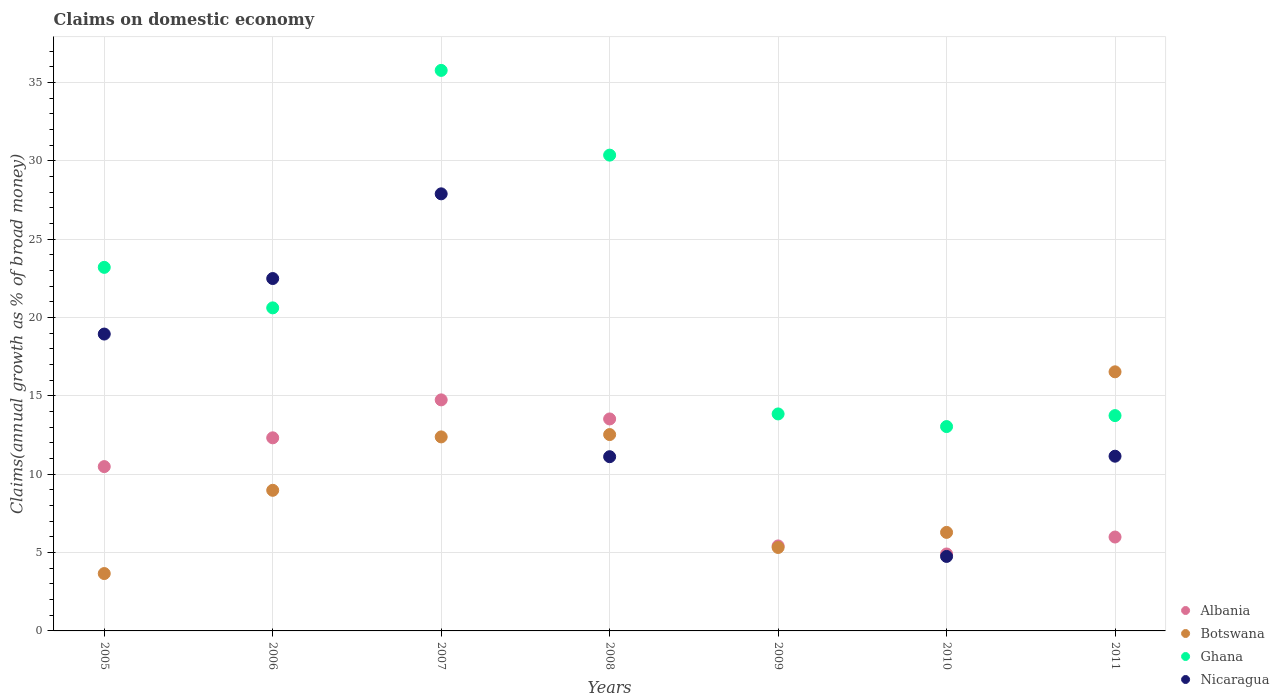What is the percentage of broad money claimed on domestic economy in Nicaragua in 2007?
Provide a succinct answer. 27.9. Across all years, what is the maximum percentage of broad money claimed on domestic economy in Albania?
Your answer should be very brief. 14.75. Across all years, what is the minimum percentage of broad money claimed on domestic economy in Ghana?
Your answer should be very brief. 13.04. In which year was the percentage of broad money claimed on domestic economy in Botswana maximum?
Offer a terse response. 2011. What is the total percentage of broad money claimed on domestic economy in Ghana in the graph?
Make the answer very short. 150.59. What is the difference between the percentage of broad money claimed on domestic economy in Albania in 2008 and that in 2010?
Offer a terse response. 8.62. What is the difference between the percentage of broad money claimed on domestic economy in Ghana in 2011 and the percentage of broad money claimed on domestic economy in Albania in 2007?
Your answer should be compact. -1. What is the average percentage of broad money claimed on domestic economy in Albania per year?
Your answer should be compact. 9.63. In the year 2008, what is the difference between the percentage of broad money claimed on domestic economy in Ghana and percentage of broad money claimed on domestic economy in Botswana?
Keep it short and to the point. 17.83. What is the ratio of the percentage of broad money claimed on domestic economy in Albania in 2008 to that in 2009?
Keep it short and to the point. 2.49. Is the percentage of broad money claimed on domestic economy in Albania in 2006 less than that in 2008?
Your answer should be very brief. Yes. What is the difference between the highest and the second highest percentage of broad money claimed on domestic economy in Botswana?
Your answer should be compact. 4. What is the difference between the highest and the lowest percentage of broad money claimed on domestic economy in Botswana?
Your answer should be very brief. 12.87. Is it the case that in every year, the sum of the percentage of broad money claimed on domestic economy in Botswana and percentage of broad money claimed on domestic economy in Nicaragua  is greater than the percentage of broad money claimed on domestic economy in Ghana?
Offer a terse response. No. Does the percentage of broad money claimed on domestic economy in Nicaragua monotonically increase over the years?
Your answer should be compact. No. Is the percentage of broad money claimed on domestic economy in Botswana strictly greater than the percentage of broad money claimed on domestic economy in Albania over the years?
Offer a very short reply. No. Is the percentage of broad money claimed on domestic economy in Albania strictly less than the percentage of broad money claimed on domestic economy in Nicaragua over the years?
Offer a terse response. No. Are the values on the major ticks of Y-axis written in scientific E-notation?
Your answer should be compact. No. Does the graph contain any zero values?
Offer a terse response. Yes. Where does the legend appear in the graph?
Offer a terse response. Bottom right. What is the title of the graph?
Offer a very short reply. Claims on domestic economy. What is the label or title of the Y-axis?
Offer a terse response. Claims(annual growth as % of broad money). What is the Claims(annual growth as % of broad money) in Albania in 2005?
Offer a terse response. 10.49. What is the Claims(annual growth as % of broad money) in Botswana in 2005?
Provide a short and direct response. 3.66. What is the Claims(annual growth as % of broad money) of Ghana in 2005?
Provide a short and direct response. 23.2. What is the Claims(annual growth as % of broad money) in Nicaragua in 2005?
Provide a short and direct response. 18.95. What is the Claims(annual growth as % of broad money) of Albania in 2006?
Offer a very short reply. 12.32. What is the Claims(annual growth as % of broad money) of Botswana in 2006?
Provide a short and direct response. 8.97. What is the Claims(annual growth as % of broad money) in Ghana in 2006?
Keep it short and to the point. 20.62. What is the Claims(annual growth as % of broad money) of Nicaragua in 2006?
Give a very brief answer. 22.49. What is the Claims(annual growth as % of broad money) in Albania in 2007?
Your response must be concise. 14.75. What is the Claims(annual growth as % of broad money) in Botswana in 2007?
Offer a very short reply. 12.38. What is the Claims(annual growth as % of broad money) of Ghana in 2007?
Your response must be concise. 35.77. What is the Claims(annual growth as % of broad money) of Nicaragua in 2007?
Your response must be concise. 27.9. What is the Claims(annual growth as % of broad money) of Albania in 2008?
Provide a succinct answer. 13.53. What is the Claims(annual growth as % of broad money) in Botswana in 2008?
Make the answer very short. 12.53. What is the Claims(annual growth as % of broad money) in Ghana in 2008?
Make the answer very short. 30.37. What is the Claims(annual growth as % of broad money) in Nicaragua in 2008?
Provide a short and direct response. 11.12. What is the Claims(annual growth as % of broad money) of Albania in 2009?
Offer a very short reply. 5.42. What is the Claims(annual growth as % of broad money) in Botswana in 2009?
Provide a succinct answer. 5.33. What is the Claims(annual growth as % of broad money) in Ghana in 2009?
Make the answer very short. 13.85. What is the Claims(annual growth as % of broad money) in Nicaragua in 2009?
Your response must be concise. 0. What is the Claims(annual growth as % of broad money) in Albania in 2010?
Ensure brevity in your answer.  4.91. What is the Claims(annual growth as % of broad money) in Botswana in 2010?
Your response must be concise. 6.29. What is the Claims(annual growth as % of broad money) in Ghana in 2010?
Provide a short and direct response. 13.04. What is the Claims(annual growth as % of broad money) of Nicaragua in 2010?
Offer a very short reply. 4.75. What is the Claims(annual growth as % of broad money) in Albania in 2011?
Offer a very short reply. 5.99. What is the Claims(annual growth as % of broad money) in Botswana in 2011?
Give a very brief answer. 16.54. What is the Claims(annual growth as % of broad money) in Ghana in 2011?
Provide a succinct answer. 13.74. What is the Claims(annual growth as % of broad money) in Nicaragua in 2011?
Offer a terse response. 11.15. Across all years, what is the maximum Claims(annual growth as % of broad money) in Albania?
Ensure brevity in your answer.  14.75. Across all years, what is the maximum Claims(annual growth as % of broad money) in Botswana?
Ensure brevity in your answer.  16.54. Across all years, what is the maximum Claims(annual growth as % of broad money) in Ghana?
Keep it short and to the point. 35.77. Across all years, what is the maximum Claims(annual growth as % of broad money) of Nicaragua?
Keep it short and to the point. 27.9. Across all years, what is the minimum Claims(annual growth as % of broad money) in Albania?
Your response must be concise. 4.91. Across all years, what is the minimum Claims(annual growth as % of broad money) in Botswana?
Keep it short and to the point. 3.66. Across all years, what is the minimum Claims(annual growth as % of broad money) of Ghana?
Make the answer very short. 13.04. What is the total Claims(annual growth as % of broad money) in Albania in the graph?
Offer a terse response. 67.41. What is the total Claims(annual growth as % of broad money) in Botswana in the graph?
Provide a short and direct response. 65.7. What is the total Claims(annual growth as % of broad money) of Ghana in the graph?
Your answer should be compact. 150.59. What is the total Claims(annual growth as % of broad money) in Nicaragua in the graph?
Keep it short and to the point. 96.36. What is the difference between the Claims(annual growth as % of broad money) in Albania in 2005 and that in 2006?
Your response must be concise. -1.84. What is the difference between the Claims(annual growth as % of broad money) in Botswana in 2005 and that in 2006?
Keep it short and to the point. -5.31. What is the difference between the Claims(annual growth as % of broad money) of Ghana in 2005 and that in 2006?
Offer a terse response. 2.59. What is the difference between the Claims(annual growth as % of broad money) of Nicaragua in 2005 and that in 2006?
Provide a short and direct response. -3.54. What is the difference between the Claims(annual growth as % of broad money) of Albania in 2005 and that in 2007?
Ensure brevity in your answer.  -4.26. What is the difference between the Claims(annual growth as % of broad money) of Botswana in 2005 and that in 2007?
Make the answer very short. -8.72. What is the difference between the Claims(annual growth as % of broad money) in Ghana in 2005 and that in 2007?
Give a very brief answer. -12.57. What is the difference between the Claims(annual growth as % of broad money) of Nicaragua in 2005 and that in 2007?
Offer a terse response. -8.95. What is the difference between the Claims(annual growth as % of broad money) of Albania in 2005 and that in 2008?
Make the answer very short. -3.04. What is the difference between the Claims(annual growth as % of broad money) in Botswana in 2005 and that in 2008?
Ensure brevity in your answer.  -8.87. What is the difference between the Claims(annual growth as % of broad money) of Ghana in 2005 and that in 2008?
Ensure brevity in your answer.  -7.16. What is the difference between the Claims(annual growth as % of broad money) in Nicaragua in 2005 and that in 2008?
Give a very brief answer. 7.83. What is the difference between the Claims(annual growth as % of broad money) in Albania in 2005 and that in 2009?
Give a very brief answer. 5.06. What is the difference between the Claims(annual growth as % of broad money) in Botswana in 2005 and that in 2009?
Offer a terse response. -1.66. What is the difference between the Claims(annual growth as % of broad money) in Ghana in 2005 and that in 2009?
Ensure brevity in your answer.  9.35. What is the difference between the Claims(annual growth as % of broad money) in Albania in 2005 and that in 2010?
Your answer should be very brief. 5.58. What is the difference between the Claims(annual growth as % of broad money) in Botswana in 2005 and that in 2010?
Offer a very short reply. -2.63. What is the difference between the Claims(annual growth as % of broad money) of Ghana in 2005 and that in 2010?
Make the answer very short. 10.16. What is the difference between the Claims(annual growth as % of broad money) of Nicaragua in 2005 and that in 2010?
Provide a short and direct response. 14.19. What is the difference between the Claims(annual growth as % of broad money) in Albania in 2005 and that in 2011?
Provide a short and direct response. 4.49. What is the difference between the Claims(annual growth as % of broad money) of Botswana in 2005 and that in 2011?
Your response must be concise. -12.87. What is the difference between the Claims(annual growth as % of broad money) of Ghana in 2005 and that in 2011?
Ensure brevity in your answer.  9.46. What is the difference between the Claims(annual growth as % of broad money) of Nicaragua in 2005 and that in 2011?
Keep it short and to the point. 7.8. What is the difference between the Claims(annual growth as % of broad money) of Albania in 2006 and that in 2007?
Ensure brevity in your answer.  -2.42. What is the difference between the Claims(annual growth as % of broad money) of Botswana in 2006 and that in 2007?
Offer a very short reply. -3.41. What is the difference between the Claims(annual growth as % of broad money) in Ghana in 2006 and that in 2007?
Keep it short and to the point. -15.16. What is the difference between the Claims(annual growth as % of broad money) of Nicaragua in 2006 and that in 2007?
Your answer should be compact. -5.41. What is the difference between the Claims(annual growth as % of broad money) of Albania in 2006 and that in 2008?
Keep it short and to the point. -1.2. What is the difference between the Claims(annual growth as % of broad money) in Botswana in 2006 and that in 2008?
Offer a very short reply. -3.56. What is the difference between the Claims(annual growth as % of broad money) of Ghana in 2006 and that in 2008?
Offer a terse response. -9.75. What is the difference between the Claims(annual growth as % of broad money) of Nicaragua in 2006 and that in 2008?
Your answer should be very brief. 11.37. What is the difference between the Claims(annual growth as % of broad money) of Albania in 2006 and that in 2009?
Offer a terse response. 6.9. What is the difference between the Claims(annual growth as % of broad money) in Botswana in 2006 and that in 2009?
Provide a succinct answer. 3.65. What is the difference between the Claims(annual growth as % of broad money) of Ghana in 2006 and that in 2009?
Make the answer very short. 6.77. What is the difference between the Claims(annual growth as % of broad money) of Albania in 2006 and that in 2010?
Keep it short and to the point. 7.41. What is the difference between the Claims(annual growth as % of broad money) in Botswana in 2006 and that in 2010?
Your response must be concise. 2.69. What is the difference between the Claims(annual growth as % of broad money) in Ghana in 2006 and that in 2010?
Offer a very short reply. 7.58. What is the difference between the Claims(annual growth as % of broad money) of Nicaragua in 2006 and that in 2010?
Make the answer very short. 17.74. What is the difference between the Claims(annual growth as % of broad money) of Albania in 2006 and that in 2011?
Provide a succinct answer. 6.33. What is the difference between the Claims(annual growth as % of broad money) of Botswana in 2006 and that in 2011?
Make the answer very short. -7.56. What is the difference between the Claims(annual growth as % of broad money) of Ghana in 2006 and that in 2011?
Offer a very short reply. 6.88. What is the difference between the Claims(annual growth as % of broad money) of Nicaragua in 2006 and that in 2011?
Keep it short and to the point. 11.34. What is the difference between the Claims(annual growth as % of broad money) of Albania in 2007 and that in 2008?
Provide a short and direct response. 1.22. What is the difference between the Claims(annual growth as % of broad money) of Botswana in 2007 and that in 2008?
Provide a short and direct response. -0.15. What is the difference between the Claims(annual growth as % of broad money) in Ghana in 2007 and that in 2008?
Your response must be concise. 5.41. What is the difference between the Claims(annual growth as % of broad money) of Nicaragua in 2007 and that in 2008?
Your answer should be compact. 16.78. What is the difference between the Claims(annual growth as % of broad money) in Albania in 2007 and that in 2009?
Ensure brevity in your answer.  9.32. What is the difference between the Claims(annual growth as % of broad money) of Botswana in 2007 and that in 2009?
Your answer should be very brief. 7.06. What is the difference between the Claims(annual growth as % of broad money) in Ghana in 2007 and that in 2009?
Provide a short and direct response. 21.92. What is the difference between the Claims(annual growth as % of broad money) of Albania in 2007 and that in 2010?
Offer a terse response. 9.84. What is the difference between the Claims(annual growth as % of broad money) of Botswana in 2007 and that in 2010?
Provide a short and direct response. 6.09. What is the difference between the Claims(annual growth as % of broad money) in Ghana in 2007 and that in 2010?
Give a very brief answer. 22.73. What is the difference between the Claims(annual growth as % of broad money) in Nicaragua in 2007 and that in 2010?
Make the answer very short. 23.14. What is the difference between the Claims(annual growth as % of broad money) of Albania in 2007 and that in 2011?
Make the answer very short. 8.75. What is the difference between the Claims(annual growth as % of broad money) of Botswana in 2007 and that in 2011?
Your answer should be compact. -4.15. What is the difference between the Claims(annual growth as % of broad money) of Ghana in 2007 and that in 2011?
Keep it short and to the point. 22.03. What is the difference between the Claims(annual growth as % of broad money) of Nicaragua in 2007 and that in 2011?
Give a very brief answer. 16.74. What is the difference between the Claims(annual growth as % of broad money) of Albania in 2008 and that in 2009?
Keep it short and to the point. 8.1. What is the difference between the Claims(annual growth as % of broad money) of Botswana in 2008 and that in 2009?
Your response must be concise. 7.21. What is the difference between the Claims(annual growth as % of broad money) of Ghana in 2008 and that in 2009?
Offer a terse response. 16.52. What is the difference between the Claims(annual growth as % of broad money) of Albania in 2008 and that in 2010?
Your answer should be compact. 8.62. What is the difference between the Claims(annual growth as % of broad money) in Botswana in 2008 and that in 2010?
Provide a short and direct response. 6.24. What is the difference between the Claims(annual growth as % of broad money) in Ghana in 2008 and that in 2010?
Make the answer very short. 17.32. What is the difference between the Claims(annual growth as % of broad money) in Nicaragua in 2008 and that in 2010?
Offer a very short reply. 6.37. What is the difference between the Claims(annual growth as % of broad money) of Albania in 2008 and that in 2011?
Provide a short and direct response. 7.54. What is the difference between the Claims(annual growth as % of broad money) in Botswana in 2008 and that in 2011?
Your answer should be very brief. -4. What is the difference between the Claims(annual growth as % of broad money) in Ghana in 2008 and that in 2011?
Ensure brevity in your answer.  16.62. What is the difference between the Claims(annual growth as % of broad money) in Nicaragua in 2008 and that in 2011?
Give a very brief answer. -0.03. What is the difference between the Claims(annual growth as % of broad money) in Albania in 2009 and that in 2010?
Make the answer very short. 0.51. What is the difference between the Claims(annual growth as % of broad money) in Botswana in 2009 and that in 2010?
Provide a short and direct response. -0.96. What is the difference between the Claims(annual growth as % of broad money) of Ghana in 2009 and that in 2010?
Provide a succinct answer. 0.81. What is the difference between the Claims(annual growth as % of broad money) of Albania in 2009 and that in 2011?
Give a very brief answer. -0.57. What is the difference between the Claims(annual growth as % of broad money) in Botswana in 2009 and that in 2011?
Your answer should be very brief. -11.21. What is the difference between the Claims(annual growth as % of broad money) of Ghana in 2009 and that in 2011?
Ensure brevity in your answer.  0.11. What is the difference between the Claims(annual growth as % of broad money) of Albania in 2010 and that in 2011?
Make the answer very short. -1.08. What is the difference between the Claims(annual growth as % of broad money) in Botswana in 2010 and that in 2011?
Ensure brevity in your answer.  -10.25. What is the difference between the Claims(annual growth as % of broad money) of Nicaragua in 2010 and that in 2011?
Your response must be concise. -6.4. What is the difference between the Claims(annual growth as % of broad money) of Albania in 2005 and the Claims(annual growth as % of broad money) of Botswana in 2006?
Your answer should be very brief. 1.51. What is the difference between the Claims(annual growth as % of broad money) of Albania in 2005 and the Claims(annual growth as % of broad money) of Ghana in 2006?
Your response must be concise. -10.13. What is the difference between the Claims(annual growth as % of broad money) in Albania in 2005 and the Claims(annual growth as % of broad money) in Nicaragua in 2006?
Ensure brevity in your answer.  -12. What is the difference between the Claims(annual growth as % of broad money) in Botswana in 2005 and the Claims(annual growth as % of broad money) in Ghana in 2006?
Give a very brief answer. -16.96. What is the difference between the Claims(annual growth as % of broad money) of Botswana in 2005 and the Claims(annual growth as % of broad money) of Nicaragua in 2006?
Your response must be concise. -18.83. What is the difference between the Claims(annual growth as % of broad money) of Ghana in 2005 and the Claims(annual growth as % of broad money) of Nicaragua in 2006?
Make the answer very short. 0.71. What is the difference between the Claims(annual growth as % of broad money) in Albania in 2005 and the Claims(annual growth as % of broad money) in Botswana in 2007?
Offer a terse response. -1.9. What is the difference between the Claims(annual growth as % of broad money) of Albania in 2005 and the Claims(annual growth as % of broad money) of Ghana in 2007?
Your answer should be very brief. -25.29. What is the difference between the Claims(annual growth as % of broad money) of Albania in 2005 and the Claims(annual growth as % of broad money) of Nicaragua in 2007?
Offer a terse response. -17.41. What is the difference between the Claims(annual growth as % of broad money) of Botswana in 2005 and the Claims(annual growth as % of broad money) of Ghana in 2007?
Make the answer very short. -32.11. What is the difference between the Claims(annual growth as % of broad money) of Botswana in 2005 and the Claims(annual growth as % of broad money) of Nicaragua in 2007?
Your answer should be compact. -24.23. What is the difference between the Claims(annual growth as % of broad money) of Ghana in 2005 and the Claims(annual growth as % of broad money) of Nicaragua in 2007?
Your answer should be compact. -4.69. What is the difference between the Claims(annual growth as % of broad money) in Albania in 2005 and the Claims(annual growth as % of broad money) in Botswana in 2008?
Offer a very short reply. -2.04. What is the difference between the Claims(annual growth as % of broad money) in Albania in 2005 and the Claims(annual growth as % of broad money) in Ghana in 2008?
Provide a succinct answer. -19.88. What is the difference between the Claims(annual growth as % of broad money) in Albania in 2005 and the Claims(annual growth as % of broad money) in Nicaragua in 2008?
Give a very brief answer. -0.63. What is the difference between the Claims(annual growth as % of broad money) in Botswana in 2005 and the Claims(annual growth as % of broad money) in Ghana in 2008?
Offer a terse response. -26.7. What is the difference between the Claims(annual growth as % of broad money) in Botswana in 2005 and the Claims(annual growth as % of broad money) in Nicaragua in 2008?
Your answer should be very brief. -7.46. What is the difference between the Claims(annual growth as % of broad money) of Ghana in 2005 and the Claims(annual growth as % of broad money) of Nicaragua in 2008?
Give a very brief answer. 12.08. What is the difference between the Claims(annual growth as % of broad money) of Albania in 2005 and the Claims(annual growth as % of broad money) of Botswana in 2009?
Your answer should be compact. 5.16. What is the difference between the Claims(annual growth as % of broad money) of Albania in 2005 and the Claims(annual growth as % of broad money) of Ghana in 2009?
Offer a very short reply. -3.36. What is the difference between the Claims(annual growth as % of broad money) of Botswana in 2005 and the Claims(annual growth as % of broad money) of Ghana in 2009?
Keep it short and to the point. -10.19. What is the difference between the Claims(annual growth as % of broad money) in Albania in 2005 and the Claims(annual growth as % of broad money) in Botswana in 2010?
Make the answer very short. 4.2. What is the difference between the Claims(annual growth as % of broad money) in Albania in 2005 and the Claims(annual growth as % of broad money) in Ghana in 2010?
Your response must be concise. -2.55. What is the difference between the Claims(annual growth as % of broad money) of Albania in 2005 and the Claims(annual growth as % of broad money) of Nicaragua in 2010?
Give a very brief answer. 5.73. What is the difference between the Claims(annual growth as % of broad money) of Botswana in 2005 and the Claims(annual growth as % of broad money) of Ghana in 2010?
Your answer should be very brief. -9.38. What is the difference between the Claims(annual growth as % of broad money) in Botswana in 2005 and the Claims(annual growth as % of broad money) in Nicaragua in 2010?
Offer a very short reply. -1.09. What is the difference between the Claims(annual growth as % of broad money) of Ghana in 2005 and the Claims(annual growth as % of broad money) of Nicaragua in 2010?
Make the answer very short. 18.45. What is the difference between the Claims(annual growth as % of broad money) of Albania in 2005 and the Claims(annual growth as % of broad money) of Botswana in 2011?
Provide a succinct answer. -6.05. What is the difference between the Claims(annual growth as % of broad money) in Albania in 2005 and the Claims(annual growth as % of broad money) in Ghana in 2011?
Your response must be concise. -3.25. What is the difference between the Claims(annual growth as % of broad money) in Albania in 2005 and the Claims(annual growth as % of broad money) in Nicaragua in 2011?
Offer a terse response. -0.66. What is the difference between the Claims(annual growth as % of broad money) in Botswana in 2005 and the Claims(annual growth as % of broad money) in Ghana in 2011?
Your response must be concise. -10.08. What is the difference between the Claims(annual growth as % of broad money) of Botswana in 2005 and the Claims(annual growth as % of broad money) of Nicaragua in 2011?
Keep it short and to the point. -7.49. What is the difference between the Claims(annual growth as % of broad money) in Ghana in 2005 and the Claims(annual growth as % of broad money) in Nicaragua in 2011?
Provide a short and direct response. 12.05. What is the difference between the Claims(annual growth as % of broad money) in Albania in 2006 and the Claims(annual growth as % of broad money) in Botswana in 2007?
Ensure brevity in your answer.  -0.06. What is the difference between the Claims(annual growth as % of broad money) in Albania in 2006 and the Claims(annual growth as % of broad money) in Ghana in 2007?
Provide a succinct answer. -23.45. What is the difference between the Claims(annual growth as % of broad money) of Albania in 2006 and the Claims(annual growth as % of broad money) of Nicaragua in 2007?
Keep it short and to the point. -15.57. What is the difference between the Claims(annual growth as % of broad money) in Botswana in 2006 and the Claims(annual growth as % of broad money) in Ghana in 2007?
Give a very brief answer. -26.8. What is the difference between the Claims(annual growth as % of broad money) in Botswana in 2006 and the Claims(annual growth as % of broad money) in Nicaragua in 2007?
Keep it short and to the point. -18.92. What is the difference between the Claims(annual growth as % of broad money) in Ghana in 2006 and the Claims(annual growth as % of broad money) in Nicaragua in 2007?
Provide a succinct answer. -7.28. What is the difference between the Claims(annual growth as % of broad money) of Albania in 2006 and the Claims(annual growth as % of broad money) of Botswana in 2008?
Make the answer very short. -0.21. What is the difference between the Claims(annual growth as % of broad money) of Albania in 2006 and the Claims(annual growth as % of broad money) of Ghana in 2008?
Offer a terse response. -18.04. What is the difference between the Claims(annual growth as % of broad money) in Albania in 2006 and the Claims(annual growth as % of broad money) in Nicaragua in 2008?
Provide a succinct answer. 1.2. What is the difference between the Claims(annual growth as % of broad money) in Botswana in 2006 and the Claims(annual growth as % of broad money) in Ghana in 2008?
Your answer should be compact. -21.39. What is the difference between the Claims(annual growth as % of broad money) of Botswana in 2006 and the Claims(annual growth as % of broad money) of Nicaragua in 2008?
Provide a short and direct response. -2.14. What is the difference between the Claims(annual growth as % of broad money) in Ghana in 2006 and the Claims(annual growth as % of broad money) in Nicaragua in 2008?
Your response must be concise. 9.5. What is the difference between the Claims(annual growth as % of broad money) in Albania in 2006 and the Claims(annual growth as % of broad money) in Botswana in 2009?
Keep it short and to the point. 7. What is the difference between the Claims(annual growth as % of broad money) in Albania in 2006 and the Claims(annual growth as % of broad money) in Ghana in 2009?
Offer a terse response. -1.52. What is the difference between the Claims(annual growth as % of broad money) in Botswana in 2006 and the Claims(annual growth as % of broad money) in Ghana in 2009?
Offer a very short reply. -4.87. What is the difference between the Claims(annual growth as % of broad money) in Albania in 2006 and the Claims(annual growth as % of broad money) in Botswana in 2010?
Offer a very short reply. 6.04. What is the difference between the Claims(annual growth as % of broad money) in Albania in 2006 and the Claims(annual growth as % of broad money) in Ghana in 2010?
Offer a very short reply. -0.72. What is the difference between the Claims(annual growth as % of broad money) of Albania in 2006 and the Claims(annual growth as % of broad money) of Nicaragua in 2010?
Offer a very short reply. 7.57. What is the difference between the Claims(annual growth as % of broad money) in Botswana in 2006 and the Claims(annual growth as % of broad money) in Ghana in 2010?
Keep it short and to the point. -4.07. What is the difference between the Claims(annual growth as % of broad money) in Botswana in 2006 and the Claims(annual growth as % of broad money) in Nicaragua in 2010?
Provide a succinct answer. 4.22. What is the difference between the Claims(annual growth as % of broad money) of Ghana in 2006 and the Claims(annual growth as % of broad money) of Nicaragua in 2010?
Your response must be concise. 15.86. What is the difference between the Claims(annual growth as % of broad money) in Albania in 2006 and the Claims(annual growth as % of broad money) in Botswana in 2011?
Give a very brief answer. -4.21. What is the difference between the Claims(annual growth as % of broad money) of Albania in 2006 and the Claims(annual growth as % of broad money) of Ghana in 2011?
Give a very brief answer. -1.42. What is the difference between the Claims(annual growth as % of broad money) of Albania in 2006 and the Claims(annual growth as % of broad money) of Nicaragua in 2011?
Ensure brevity in your answer.  1.17. What is the difference between the Claims(annual growth as % of broad money) in Botswana in 2006 and the Claims(annual growth as % of broad money) in Ghana in 2011?
Your answer should be very brief. -4.77. What is the difference between the Claims(annual growth as % of broad money) of Botswana in 2006 and the Claims(annual growth as % of broad money) of Nicaragua in 2011?
Make the answer very short. -2.18. What is the difference between the Claims(annual growth as % of broad money) of Ghana in 2006 and the Claims(annual growth as % of broad money) of Nicaragua in 2011?
Your response must be concise. 9.47. What is the difference between the Claims(annual growth as % of broad money) of Albania in 2007 and the Claims(annual growth as % of broad money) of Botswana in 2008?
Make the answer very short. 2.21. What is the difference between the Claims(annual growth as % of broad money) of Albania in 2007 and the Claims(annual growth as % of broad money) of Ghana in 2008?
Offer a terse response. -15.62. What is the difference between the Claims(annual growth as % of broad money) in Albania in 2007 and the Claims(annual growth as % of broad money) in Nicaragua in 2008?
Your response must be concise. 3.63. What is the difference between the Claims(annual growth as % of broad money) in Botswana in 2007 and the Claims(annual growth as % of broad money) in Ghana in 2008?
Your response must be concise. -17.98. What is the difference between the Claims(annual growth as % of broad money) of Botswana in 2007 and the Claims(annual growth as % of broad money) of Nicaragua in 2008?
Your answer should be compact. 1.26. What is the difference between the Claims(annual growth as % of broad money) of Ghana in 2007 and the Claims(annual growth as % of broad money) of Nicaragua in 2008?
Offer a very short reply. 24.65. What is the difference between the Claims(annual growth as % of broad money) in Albania in 2007 and the Claims(annual growth as % of broad money) in Botswana in 2009?
Your answer should be compact. 9.42. What is the difference between the Claims(annual growth as % of broad money) in Albania in 2007 and the Claims(annual growth as % of broad money) in Ghana in 2009?
Make the answer very short. 0.9. What is the difference between the Claims(annual growth as % of broad money) in Botswana in 2007 and the Claims(annual growth as % of broad money) in Ghana in 2009?
Ensure brevity in your answer.  -1.47. What is the difference between the Claims(annual growth as % of broad money) of Albania in 2007 and the Claims(annual growth as % of broad money) of Botswana in 2010?
Provide a short and direct response. 8.46. What is the difference between the Claims(annual growth as % of broad money) of Albania in 2007 and the Claims(annual growth as % of broad money) of Ghana in 2010?
Keep it short and to the point. 1.7. What is the difference between the Claims(annual growth as % of broad money) of Albania in 2007 and the Claims(annual growth as % of broad money) of Nicaragua in 2010?
Give a very brief answer. 9.99. What is the difference between the Claims(annual growth as % of broad money) in Botswana in 2007 and the Claims(annual growth as % of broad money) in Ghana in 2010?
Ensure brevity in your answer.  -0.66. What is the difference between the Claims(annual growth as % of broad money) in Botswana in 2007 and the Claims(annual growth as % of broad money) in Nicaragua in 2010?
Provide a short and direct response. 7.63. What is the difference between the Claims(annual growth as % of broad money) in Ghana in 2007 and the Claims(annual growth as % of broad money) in Nicaragua in 2010?
Provide a short and direct response. 31.02. What is the difference between the Claims(annual growth as % of broad money) in Albania in 2007 and the Claims(annual growth as % of broad money) in Botswana in 2011?
Your answer should be compact. -1.79. What is the difference between the Claims(annual growth as % of broad money) of Albania in 2007 and the Claims(annual growth as % of broad money) of Nicaragua in 2011?
Your answer should be compact. 3.6. What is the difference between the Claims(annual growth as % of broad money) of Botswana in 2007 and the Claims(annual growth as % of broad money) of Ghana in 2011?
Offer a terse response. -1.36. What is the difference between the Claims(annual growth as % of broad money) in Botswana in 2007 and the Claims(annual growth as % of broad money) in Nicaragua in 2011?
Give a very brief answer. 1.23. What is the difference between the Claims(annual growth as % of broad money) in Ghana in 2007 and the Claims(annual growth as % of broad money) in Nicaragua in 2011?
Provide a short and direct response. 24.62. What is the difference between the Claims(annual growth as % of broad money) in Albania in 2008 and the Claims(annual growth as % of broad money) in Botswana in 2009?
Offer a very short reply. 8.2. What is the difference between the Claims(annual growth as % of broad money) of Albania in 2008 and the Claims(annual growth as % of broad money) of Ghana in 2009?
Your answer should be compact. -0.32. What is the difference between the Claims(annual growth as % of broad money) of Botswana in 2008 and the Claims(annual growth as % of broad money) of Ghana in 2009?
Your answer should be very brief. -1.32. What is the difference between the Claims(annual growth as % of broad money) of Albania in 2008 and the Claims(annual growth as % of broad money) of Botswana in 2010?
Your answer should be compact. 7.24. What is the difference between the Claims(annual growth as % of broad money) of Albania in 2008 and the Claims(annual growth as % of broad money) of Ghana in 2010?
Keep it short and to the point. 0.49. What is the difference between the Claims(annual growth as % of broad money) in Albania in 2008 and the Claims(annual growth as % of broad money) in Nicaragua in 2010?
Offer a very short reply. 8.77. What is the difference between the Claims(annual growth as % of broad money) in Botswana in 2008 and the Claims(annual growth as % of broad money) in Ghana in 2010?
Your answer should be compact. -0.51. What is the difference between the Claims(annual growth as % of broad money) of Botswana in 2008 and the Claims(annual growth as % of broad money) of Nicaragua in 2010?
Your answer should be compact. 7.78. What is the difference between the Claims(annual growth as % of broad money) of Ghana in 2008 and the Claims(annual growth as % of broad money) of Nicaragua in 2010?
Ensure brevity in your answer.  25.61. What is the difference between the Claims(annual growth as % of broad money) of Albania in 2008 and the Claims(annual growth as % of broad money) of Botswana in 2011?
Your answer should be compact. -3.01. What is the difference between the Claims(annual growth as % of broad money) of Albania in 2008 and the Claims(annual growth as % of broad money) of Ghana in 2011?
Your answer should be compact. -0.21. What is the difference between the Claims(annual growth as % of broad money) in Albania in 2008 and the Claims(annual growth as % of broad money) in Nicaragua in 2011?
Offer a very short reply. 2.38. What is the difference between the Claims(annual growth as % of broad money) of Botswana in 2008 and the Claims(annual growth as % of broad money) of Ghana in 2011?
Your answer should be compact. -1.21. What is the difference between the Claims(annual growth as % of broad money) of Botswana in 2008 and the Claims(annual growth as % of broad money) of Nicaragua in 2011?
Provide a succinct answer. 1.38. What is the difference between the Claims(annual growth as % of broad money) of Ghana in 2008 and the Claims(annual growth as % of broad money) of Nicaragua in 2011?
Your response must be concise. 19.21. What is the difference between the Claims(annual growth as % of broad money) of Albania in 2009 and the Claims(annual growth as % of broad money) of Botswana in 2010?
Give a very brief answer. -0.86. What is the difference between the Claims(annual growth as % of broad money) in Albania in 2009 and the Claims(annual growth as % of broad money) in Ghana in 2010?
Give a very brief answer. -7.62. What is the difference between the Claims(annual growth as % of broad money) of Albania in 2009 and the Claims(annual growth as % of broad money) of Nicaragua in 2010?
Provide a succinct answer. 0.67. What is the difference between the Claims(annual growth as % of broad money) of Botswana in 2009 and the Claims(annual growth as % of broad money) of Ghana in 2010?
Ensure brevity in your answer.  -7.72. What is the difference between the Claims(annual growth as % of broad money) in Botswana in 2009 and the Claims(annual growth as % of broad money) in Nicaragua in 2010?
Your answer should be compact. 0.57. What is the difference between the Claims(annual growth as % of broad money) in Ghana in 2009 and the Claims(annual growth as % of broad money) in Nicaragua in 2010?
Keep it short and to the point. 9.09. What is the difference between the Claims(annual growth as % of broad money) of Albania in 2009 and the Claims(annual growth as % of broad money) of Botswana in 2011?
Provide a succinct answer. -11.11. What is the difference between the Claims(annual growth as % of broad money) in Albania in 2009 and the Claims(annual growth as % of broad money) in Ghana in 2011?
Provide a succinct answer. -8.32. What is the difference between the Claims(annual growth as % of broad money) of Albania in 2009 and the Claims(annual growth as % of broad money) of Nicaragua in 2011?
Your answer should be compact. -5.73. What is the difference between the Claims(annual growth as % of broad money) in Botswana in 2009 and the Claims(annual growth as % of broad money) in Ghana in 2011?
Your answer should be compact. -8.42. What is the difference between the Claims(annual growth as % of broad money) of Botswana in 2009 and the Claims(annual growth as % of broad money) of Nicaragua in 2011?
Offer a very short reply. -5.83. What is the difference between the Claims(annual growth as % of broad money) of Ghana in 2009 and the Claims(annual growth as % of broad money) of Nicaragua in 2011?
Keep it short and to the point. 2.7. What is the difference between the Claims(annual growth as % of broad money) of Albania in 2010 and the Claims(annual growth as % of broad money) of Botswana in 2011?
Your answer should be very brief. -11.63. What is the difference between the Claims(annual growth as % of broad money) of Albania in 2010 and the Claims(annual growth as % of broad money) of Ghana in 2011?
Give a very brief answer. -8.83. What is the difference between the Claims(annual growth as % of broad money) in Albania in 2010 and the Claims(annual growth as % of broad money) in Nicaragua in 2011?
Ensure brevity in your answer.  -6.24. What is the difference between the Claims(annual growth as % of broad money) in Botswana in 2010 and the Claims(annual growth as % of broad money) in Ghana in 2011?
Offer a terse response. -7.45. What is the difference between the Claims(annual growth as % of broad money) of Botswana in 2010 and the Claims(annual growth as % of broad money) of Nicaragua in 2011?
Make the answer very short. -4.86. What is the difference between the Claims(annual growth as % of broad money) of Ghana in 2010 and the Claims(annual growth as % of broad money) of Nicaragua in 2011?
Ensure brevity in your answer.  1.89. What is the average Claims(annual growth as % of broad money) in Albania per year?
Offer a very short reply. 9.63. What is the average Claims(annual growth as % of broad money) of Botswana per year?
Your answer should be compact. 9.39. What is the average Claims(annual growth as % of broad money) of Ghana per year?
Offer a very short reply. 21.51. What is the average Claims(annual growth as % of broad money) of Nicaragua per year?
Offer a very short reply. 13.77. In the year 2005, what is the difference between the Claims(annual growth as % of broad money) in Albania and Claims(annual growth as % of broad money) in Botswana?
Your answer should be compact. 6.83. In the year 2005, what is the difference between the Claims(annual growth as % of broad money) in Albania and Claims(annual growth as % of broad money) in Ghana?
Your answer should be compact. -12.72. In the year 2005, what is the difference between the Claims(annual growth as % of broad money) of Albania and Claims(annual growth as % of broad money) of Nicaragua?
Provide a succinct answer. -8.46. In the year 2005, what is the difference between the Claims(annual growth as % of broad money) in Botswana and Claims(annual growth as % of broad money) in Ghana?
Keep it short and to the point. -19.54. In the year 2005, what is the difference between the Claims(annual growth as % of broad money) of Botswana and Claims(annual growth as % of broad money) of Nicaragua?
Provide a succinct answer. -15.29. In the year 2005, what is the difference between the Claims(annual growth as % of broad money) in Ghana and Claims(annual growth as % of broad money) in Nicaragua?
Offer a very short reply. 4.26. In the year 2006, what is the difference between the Claims(annual growth as % of broad money) in Albania and Claims(annual growth as % of broad money) in Botswana?
Make the answer very short. 3.35. In the year 2006, what is the difference between the Claims(annual growth as % of broad money) in Albania and Claims(annual growth as % of broad money) in Ghana?
Your response must be concise. -8.29. In the year 2006, what is the difference between the Claims(annual growth as % of broad money) of Albania and Claims(annual growth as % of broad money) of Nicaragua?
Ensure brevity in your answer.  -10.17. In the year 2006, what is the difference between the Claims(annual growth as % of broad money) in Botswana and Claims(annual growth as % of broad money) in Ghana?
Ensure brevity in your answer.  -11.64. In the year 2006, what is the difference between the Claims(annual growth as % of broad money) in Botswana and Claims(annual growth as % of broad money) in Nicaragua?
Make the answer very short. -13.52. In the year 2006, what is the difference between the Claims(annual growth as % of broad money) in Ghana and Claims(annual growth as % of broad money) in Nicaragua?
Your answer should be compact. -1.87. In the year 2007, what is the difference between the Claims(annual growth as % of broad money) in Albania and Claims(annual growth as % of broad money) in Botswana?
Your answer should be very brief. 2.36. In the year 2007, what is the difference between the Claims(annual growth as % of broad money) of Albania and Claims(annual growth as % of broad money) of Ghana?
Your answer should be compact. -21.03. In the year 2007, what is the difference between the Claims(annual growth as % of broad money) of Albania and Claims(annual growth as % of broad money) of Nicaragua?
Your answer should be very brief. -13.15. In the year 2007, what is the difference between the Claims(annual growth as % of broad money) in Botswana and Claims(annual growth as % of broad money) in Ghana?
Make the answer very short. -23.39. In the year 2007, what is the difference between the Claims(annual growth as % of broad money) of Botswana and Claims(annual growth as % of broad money) of Nicaragua?
Your response must be concise. -15.51. In the year 2007, what is the difference between the Claims(annual growth as % of broad money) in Ghana and Claims(annual growth as % of broad money) in Nicaragua?
Offer a terse response. 7.88. In the year 2008, what is the difference between the Claims(annual growth as % of broad money) of Albania and Claims(annual growth as % of broad money) of Botswana?
Offer a terse response. 1. In the year 2008, what is the difference between the Claims(annual growth as % of broad money) in Albania and Claims(annual growth as % of broad money) in Ghana?
Offer a terse response. -16.84. In the year 2008, what is the difference between the Claims(annual growth as % of broad money) of Albania and Claims(annual growth as % of broad money) of Nicaragua?
Offer a very short reply. 2.41. In the year 2008, what is the difference between the Claims(annual growth as % of broad money) of Botswana and Claims(annual growth as % of broad money) of Ghana?
Provide a short and direct response. -17.83. In the year 2008, what is the difference between the Claims(annual growth as % of broad money) of Botswana and Claims(annual growth as % of broad money) of Nicaragua?
Keep it short and to the point. 1.41. In the year 2008, what is the difference between the Claims(annual growth as % of broad money) in Ghana and Claims(annual growth as % of broad money) in Nicaragua?
Ensure brevity in your answer.  19.25. In the year 2009, what is the difference between the Claims(annual growth as % of broad money) in Albania and Claims(annual growth as % of broad money) in Botswana?
Keep it short and to the point. 0.1. In the year 2009, what is the difference between the Claims(annual growth as % of broad money) of Albania and Claims(annual growth as % of broad money) of Ghana?
Provide a short and direct response. -8.42. In the year 2009, what is the difference between the Claims(annual growth as % of broad money) of Botswana and Claims(annual growth as % of broad money) of Ghana?
Your answer should be very brief. -8.52. In the year 2010, what is the difference between the Claims(annual growth as % of broad money) of Albania and Claims(annual growth as % of broad money) of Botswana?
Give a very brief answer. -1.38. In the year 2010, what is the difference between the Claims(annual growth as % of broad money) of Albania and Claims(annual growth as % of broad money) of Ghana?
Your answer should be very brief. -8.13. In the year 2010, what is the difference between the Claims(annual growth as % of broad money) of Albania and Claims(annual growth as % of broad money) of Nicaragua?
Offer a terse response. 0.16. In the year 2010, what is the difference between the Claims(annual growth as % of broad money) in Botswana and Claims(annual growth as % of broad money) in Ghana?
Offer a terse response. -6.75. In the year 2010, what is the difference between the Claims(annual growth as % of broad money) in Botswana and Claims(annual growth as % of broad money) in Nicaragua?
Provide a succinct answer. 1.53. In the year 2010, what is the difference between the Claims(annual growth as % of broad money) in Ghana and Claims(annual growth as % of broad money) in Nicaragua?
Ensure brevity in your answer.  8.29. In the year 2011, what is the difference between the Claims(annual growth as % of broad money) of Albania and Claims(annual growth as % of broad money) of Botswana?
Your response must be concise. -10.54. In the year 2011, what is the difference between the Claims(annual growth as % of broad money) of Albania and Claims(annual growth as % of broad money) of Ghana?
Offer a terse response. -7.75. In the year 2011, what is the difference between the Claims(annual growth as % of broad money) in Albania and Claims(annual growth as % of broad money) in Nicaragua?
Ensure brevity in your answer.  -5.16. In the year 2011, what is the difference between the Claims(annual growth as % of broad money) of Botswana and Claims(annual growth as % of broad money) of Ghana?
Provide a short and direct response. 2.79. In the year 2011, what is the difference between the Claims(annual growth as % of broad money) of Botswana and Claims(annual growth as % of broad money) of Nicaragua?
Provide a succinct answer. 5.39. In the year 2011, what is the difference between the Claims(annual growth as % of broad money) of Ghana and Claims(annual growth as % of broad money) of Nicaragua?
Provide a succinct answer. 2.59. What is the ratio of the Claims(annual growth as % of broad money) in Albania in 2005 to that in 2006?
Your response must be concise. 0.85. What is the ratio of the Claims(annual growth as % of broad money) in Botswana in 2005 to that in 2006?
Offer a terse response. 0.41. What is the ratio of the Claims(annual growth as % of broad money) in Ghana in 2005 to that in 2006?
Offer a terse response. 1.13. What is the ratio of the Claims(annual growth as % of broad money) in Nicaragua in 2005 to that in 2006?
Provide a short and direct response. 0.84. What is the ratio of the Claims(annual growth as % of broad money) in Albania in 2005 to that in 2007?
Provide a succinct answer. 0.71. What is the ratio of the Claims(annual growth as % of broad money) of Botswana in 2005 to that in 2007?
Keep it short and to the point. 0.3. What is the ratio of the Claims(annual growth as % of broad money) in Ghana in 2005 to that in 2007?
Make the answer very short. 0.65. What is the ratio of the Claims(annual growth as % of broad money) in Nicaragua in 2005 to that in 2007?
Offer a terse response. 0.68. What is the ratio of the Claims(annual growth as % of broad money) of Albania in 2005 to that in 2008?
Give a very brief answer. 0.78. What is the ratio of the Claims(annual growth as % of broad money) of Botswana in 2005 to that in 2008?
Your response must be concise. 0.29. What is the ratio of the Claims(annual growth as % of broad money) in Ghana in 2005 to that in 2008?
Make the answer very short. 0.76. What is the ratio of the Claims(annual growth as % of broad money) in Nicaragua in 2005 to that in 2008?
Your response must be concise. 1.7. What is the ratio of the Claims(annual growth as % of broad money) of Albania in 2005 to that in 2009?
Ensure brevity in your answer.  1.93. What is the ratio of the Claims(annual growth as % of broad money) of Botswana in 2005 to that in 2009?
Ensure brevity in your answer.  0.69. What is the ratio of the Claims(annual growth as % of broad money) of Ghana in 2005 to that in 2009?
Offer a very short reply. 1.68. What is the ratio of the Claims(annual growth as % of broad money) of Albania in 2005 to that in 2010?
Ensure brevity in your answer.  2.14. What is the ratio of the Claims(annual growth as % of broad money) of Botswana in 2005 to that in 2010?
Give a very brief answer. 0.58. What is the ratio of the Claims(annual growth as % of broad money) in Ghana in 2005 to that in 2010?
Your answer should be very brief. 1.78. What is the ratio of the Claims(annual growth as % of broad money) in Nicaragua in 2005 to that in 2010?
Provide a succinct answer. 3.99. What is the ratio of the Claims(annual growth as % of broad money) of Albania in 2005 to that in 2011?
Give a very brief answer. 1.75. What is the ratio of the Claims(annual growth as % of broad money) in Botswana in 2005 to that in 2011?
Offer a terse response. 0.22. What is the ratio of the Claims(annual growth as % of broad money) of Ghana in 2005 to that in 2011?
Give a very brief answer. 1.69. What is the ratio of the Claims(annual growth as % of broad money) of Nicaragua in 2005 to that in 2011?
Ensure brevity in your answer.  1.7. What is the ratio of the Claims(annual growth as % of broad money) of Albania in 2006 to that in 2007?
Keep it short and to the point. 0.84. What is the ratio of the Claims(annual growth as % of broad money) in Botswana in 2006 to that in 2007?
Provide a short and direct response. 0.72. What is the ratio of the Claims(annual growth as % of broad money) of Ghana in 2006 to that in 2007?
Provide a short and direct response. 0.58. What is the ratio of the Claims(annual growth as % of broad money) of Nicaragua in 2006 to that in 2007?
Ensure brevity in your answer.  0.81. What is the ratio of the Claims(annual growth as % of broad money) in Albania in 2006 to that in 2008?
Your response must be concise. 0.91. What is the ratio of the Claims(annual growth as % of broad money) in Botswana in 2006 to that in 2008?
Keep it short and to the point. 0.72. What is the ratio of the Claims(annual growth as % of broad money) in Ghana in 2006 to that in 2008?
Make the answer very short. 0.68. What is the ratio of the Claims(annual growth as % of broad money) of Nicaragua in 2006 to that in 2008?
Give a very brief answer. 2.02. What is the ratio of the Claims(annual growth as % of broad money) in Albania in 2006 to that in 2009?
Offer a terse response. 2.27. What is the ratio of the Claims(annual growth as % of broad money) of Botswana in 2006 to that in 2009?
Offer a terse response. 1.69. What is the ratio of the Claims(annual growth as % of broad money) in Ghana in 2006 to that in 2009?
Make the answer very short. 1.49. What is the ratio of the Claims(annual growth as % of broad money) in Albania in 2006 to that in 2010?
Ensure brevity in your answer.  2.51. What is the ratio of the Claims(annual growth as % of broad money) in Botswana in 2006 to that in 2010?
Your answer should be very brief. 1.43. What is the ratio of the Claims(annual growth as % of broad money) of Ghana in 2006 to that in 2010?
Provide a short and direct response. 1.58. What is the ratio of the Claims(annual growth as % of broad money) of Nicaragua in 2006 to that in 2010?
Keep it short and to the point. 4.73. What is the ratio of the Claims(annual growth as % of broad money) of Albania in 2006 to that in 2011?
Provide a short and direct response. 2.06. What is the ratio of the Claims(annual growth as % of broad money) of Botswana in 2006 to that in 2011?
Give a very brief answer. 0.54. What is the ratio of the Claims(annual growth as % of broad money) of Ghana in 2006 to that in 2011?
Your answer should be very brief. 1.5. What is the ratio of the Claims(annual growth as % of broad money) in Nicaragua in 2006 to that in 2011?
Your response must be concise. 2.02. What is the ratio of the Claims(annual growth as % of broad money) of Albania in 2007 to that in 2008?
Provide a succinct answer. 1.09. What is the ratio of the Claims(annual growth as % of broad money) of Botswana in 2007 to that in 2008?
Provide a short and direct response. 0.99. What is the ratio of the Claims(annual growth as % of broad money) in Ghana in 2007 to that in 2008?
Make the answer very short. 1.18. What is the ratio of the Claims(annual growth as % of broad money) in Nicaragua in 2007 to that in 2008?
Your response must be concise. 2.51. What is the ratio of the Claims(annual growth as % of broad money) in Albania in 2007 to that in 2009?
Offer a terse response. 2.72. What is the ratio of the Claims(annual growth as % of broad money) of Botswana in 2007 to that in 2009?
Ensure brevity in your answer.  2.33. What is the ratio of the Claims(annual growth as % of broad money) of Ghana in 2007 to that in 2009?
Offer a terse response. 2.58. What is the ratio of the Claims(annual growth as % of broad money) in Albania in 2007 to that in 2010?
Make the answer very short. 3. What is the ratio of the Claims(annual growth as % of broad money) of Botswana in 2007 to that in 2010?
Ensure brevity in your answer.  1.97. What is the ratio of the Claims(annual growth as % of broad money) in Ghana in 2007 to that in 2010?
Offer a very short reply. 2.74. What is the ratio of the Claims(annual growth as % of broad money) in Nicaragua in 2007 to that in 2010?
Keep it short and to the point. 5.87. What is the ratio of the Claims(annual growth as % of broad money) of Albania in 2007 to that in 2011?
Make the answer very short. 2.46. What is the ratio of the Claims(annual growth as % of broad money) in Botswana in 2007 to that in 2011?
Keep it short and to the point. 0.75. What is the ratio of the Claims(annual growth as % of broad money) of Ghana in 2007 to that in 2011?
Your answer should be very brief. 2.6. What is the ratio of the Claims(annual growth as % of broad money) in Nicaragua in 2007 to that in 2011?
Your response must be concise. 2.5. What is the ratio of the Claims(annual growth as % of broad money) in Albania in 2008 to that in 2009?
Make the answer very short. 2.49. What is the ratio of the Claims(annual growth as % of broad money) in Botswana in 2008 to that in 2009?
Ensure brevity in your answer.  2.35. What is the ratio of the Claims(annual growth as % of broad money) of Ghana in 2008 to that in 2009?
Your answer should be compact. 2.19. What is the ratio of the Claims(annual growth as % of broad money) of Albania in 2008 to that in 2010?
Your answer should be compact. 2.75. What is the ratio of the Claims(annual growth as % of broad money) in Botswana in 2008 to that in 2010?
Your response must be concise. 1.99. What is the ratio of the Claims(annual growth as % of broad money) in Ghana in 2008 to that in 2010?
Give a very brief answer. 2.33. What is the ratio of the Claims(annual growth as % of broad money) of Nicaragua in 2008 to that in 2010?
Your answer should be very brief. 2.34. What is the ratio of the Claims(annual growth as % of broad money) in Albania in 2008 to that in 2011?
Offer a terse response. 2.26. What is the ratio of the Claims(annual growth as % of broad money) of Botswana in 2008 to that in 2011?
Your response must be concise. 0.76. What is the ratio of the Claims(annual growth as % of broad money) in Ghana in 2008 to that in 2011?
Make the answer very short. 2.21. What is the ratio of the Claims(annual growth as % of broad money) of Albania in 2009 to that in 2010?
Offer a terse response. 1.1. What is the ratio of the Claims(annual growth as % of broad money) of Botswana in 2009 to that in 2010?
Provide a short and direct response. 0.85. What is the ratio of the Claims(annual growth as % of broad money) in Ghana in 2009 to that in 2010?
Keep it short and to the point. 1.06. What is the ratio of the Claims(annual growth as % of broad money) of Albania in 2009 to that in 2011?
Ensure brevity in your answer.  0.91. What is the ratio of the Claims(annual growth as % of broad money) of Botswana in 2009 to that in 2011?
Give a very brief answer. 0.32. What is the ratio of the Claims(annual growth as % of broad money) in Ghana in 2009 to that in 2011?
Your answer should be very brief. 1.01. What is the ratio of the Claims(annual growth as % of broad money) in Albania in 2010 to that in 2011?
Offer a terse response. 0.82. What is the ratio of the Claims(annual growth as % of broad money) of Botswana in 2010 to that in 2011?
Offer a very short reply. 0.38. What is the ratio of the Claims(annual growth as % of broad money) in Ghana in 2010 to that in 2011?
Your answer should be very brief. 0.95. What is the ratio of the Claims(annual growth as % of broad money) in Nicaragua in 2010 to that in 2011?
Make the answer very short. 0.43. What is the difference between the highest and the second highest Claims(annual growth as % of broad money) in Albania?
Provide a succinct answer. 1.22. What is the difference between the highest and the second highest Claims(annual growth as % of broad money) in Botswana?
Offer a terse response. 4. What is the difference between the highest and the second highest Claims(annual growth as % of broad money) of Ghana?
Make the answer very short. 5.41. What is the difference between the highest and the second highest Claims(annual growth as % of broad money) in Nicaragua?
Your answer should be very brief. 5.41. What is the difference between the highest and the lowest Claims(annual growth as % of broad money) of Albania?
Your response must be concise. 9.84. What is the difference between the highest and the lowest Claims(annual growth as % of broad money) in Botswana?
Your answer should be very brief. 12.87. What is the difference between the highest and the lowest Claims(annual growth as % of broad money) of Ghana?
Offer a very short reply. 22.73. What is the difference between the highest and the lowest Claims(annual growth as % of broad money) in Nicaragua?
Offer a terse response. 27.9. 